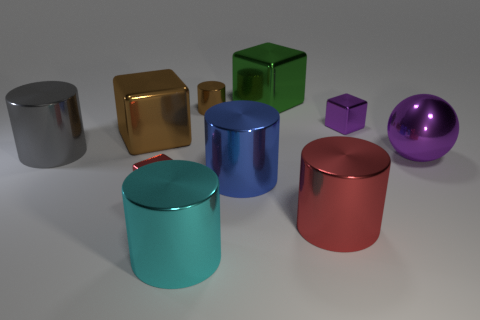What size is the cylinder that is behind the purple ball and in front of the brown metallic cylinder?
Provide a succinct answer. Large. Is the shape of the tiny object in front of the ball the same as  the large red shiny thing?
Your response must be concise. No. There is a red metal object left of the metallic thing behind the cylinder that is behind the large gray metal object; what is its size?
Your answer should be very brief. Small. What is the size of the metallic cube that is the same color as the ball?
Your answer should be compact. Small. What number of things are tiny green shiny cylinders or metallic objects?
Make the answer very short. 10. There is a large shiny thing that is left of the blue metallic object and to the right of the big brown shiny object; what is its shape?
Offer a terse response. Cylinder. Does the big purple metallic object have the same shape as the large brown shiny thing behind the large gray object?
Give a very brief answer. No. Are there any big metallic cylinders left of the red shiny cylinder?
Give a very brief answer. Yes. What number of cubes are either big green metallic objects or brown shiny things?
Keep it short and to the point. 2. Do the tiny purple object and the big purple object have the same shape?
Your answer should be very brief. No. 